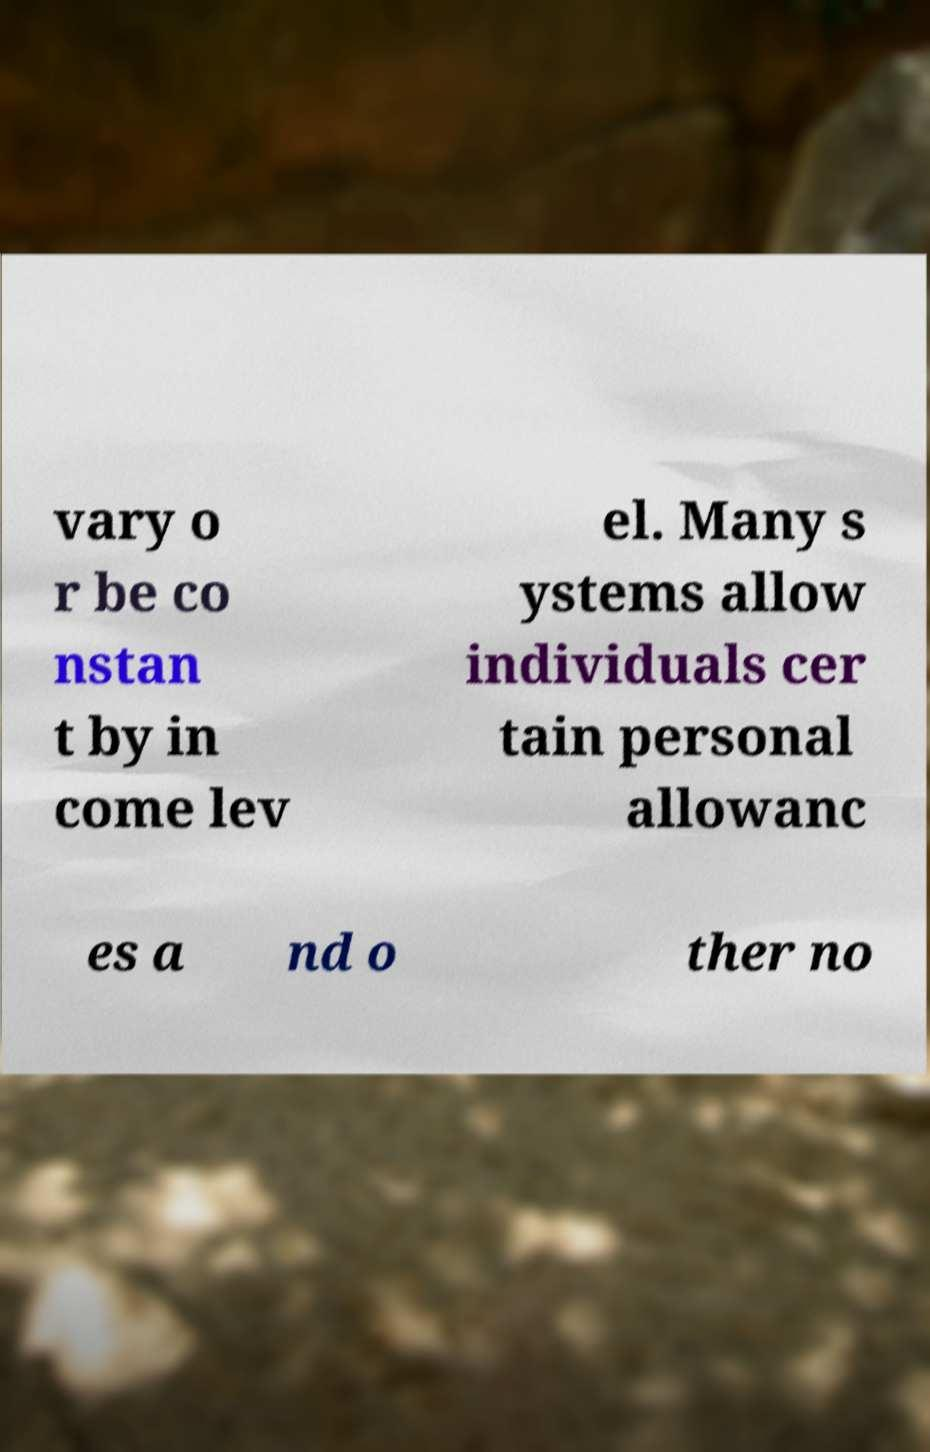What messages or text are displayed in this image? I need them in a readable, typed format. vary o r be co nstan t by in come lev el. Many s ystems allow individuals cer tain personal allowanc es a nd o ther no 